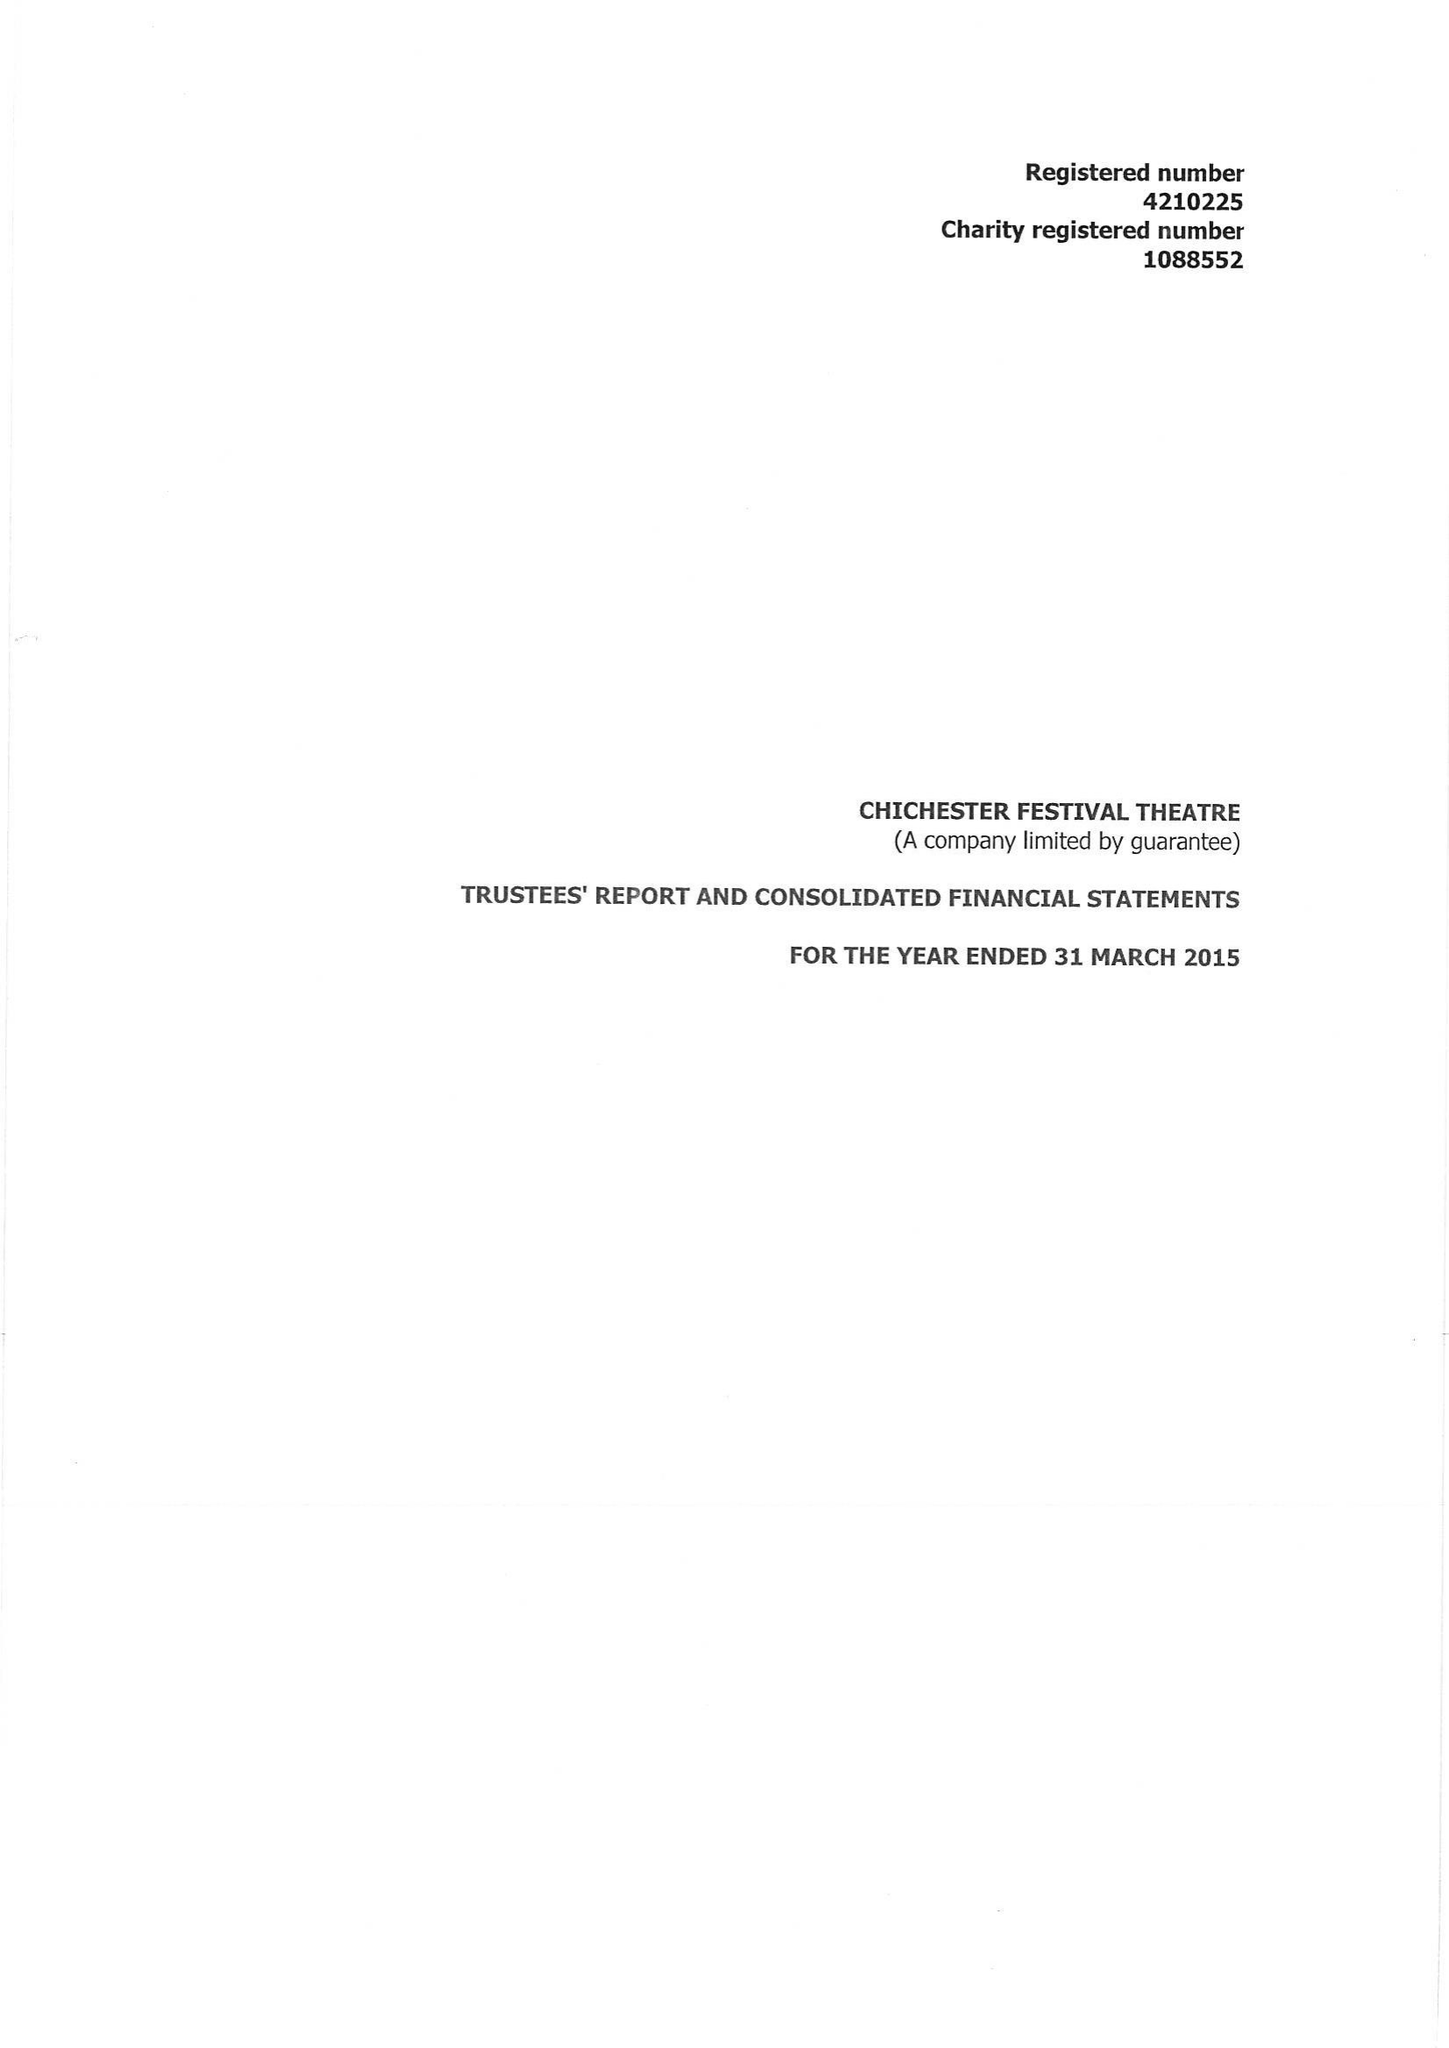What is the value for the address__street_line?
Answer the question using a single word or phrase. OAKLANDS PARK 